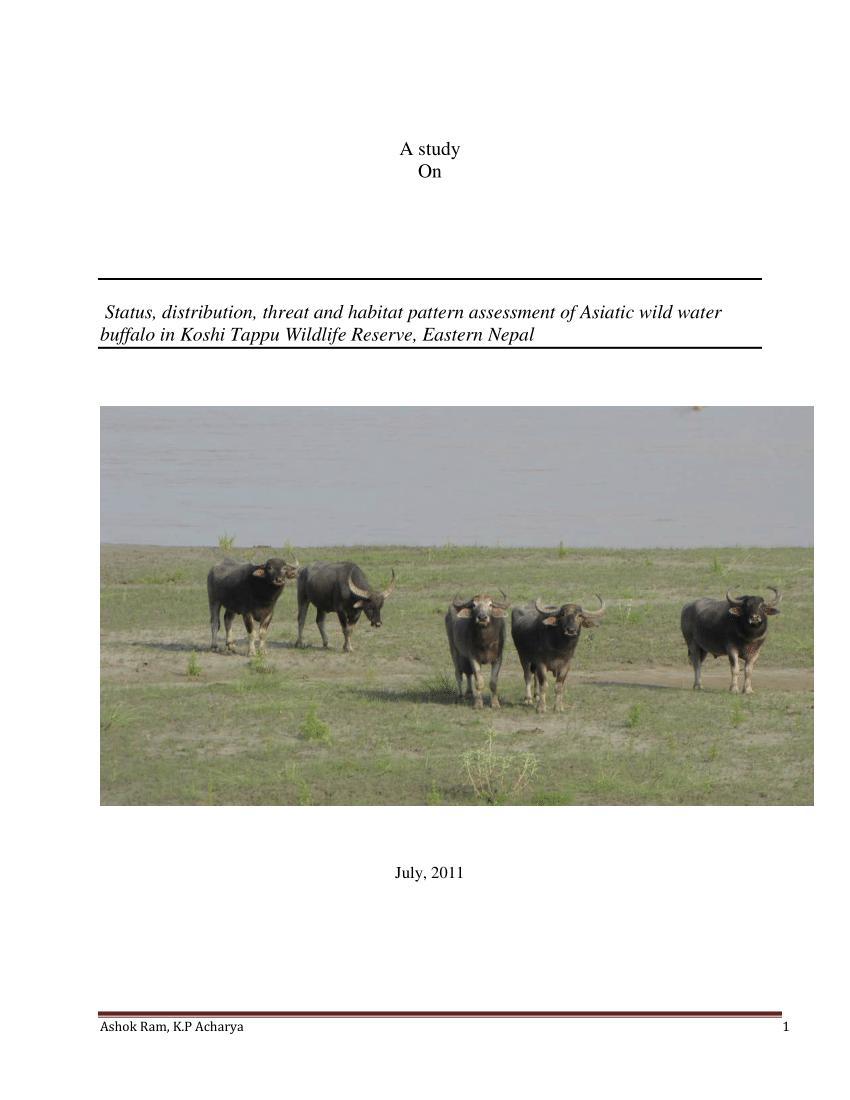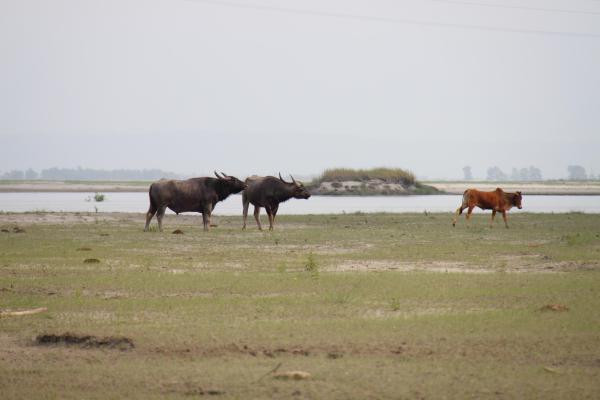The first image is the image on the left, the second image is the image on the right. Analyze the images presented: Is the assertion "At least one of the images includes a body of water that there are no water buffalos in." valid? Answer yes or no. Yes. The first image is the image on the left, the second image is the image on the right. Examine the images to the left and right. Is the description "At least one image in the pair contains only one ox." accurate? Answer yes or no. No. 